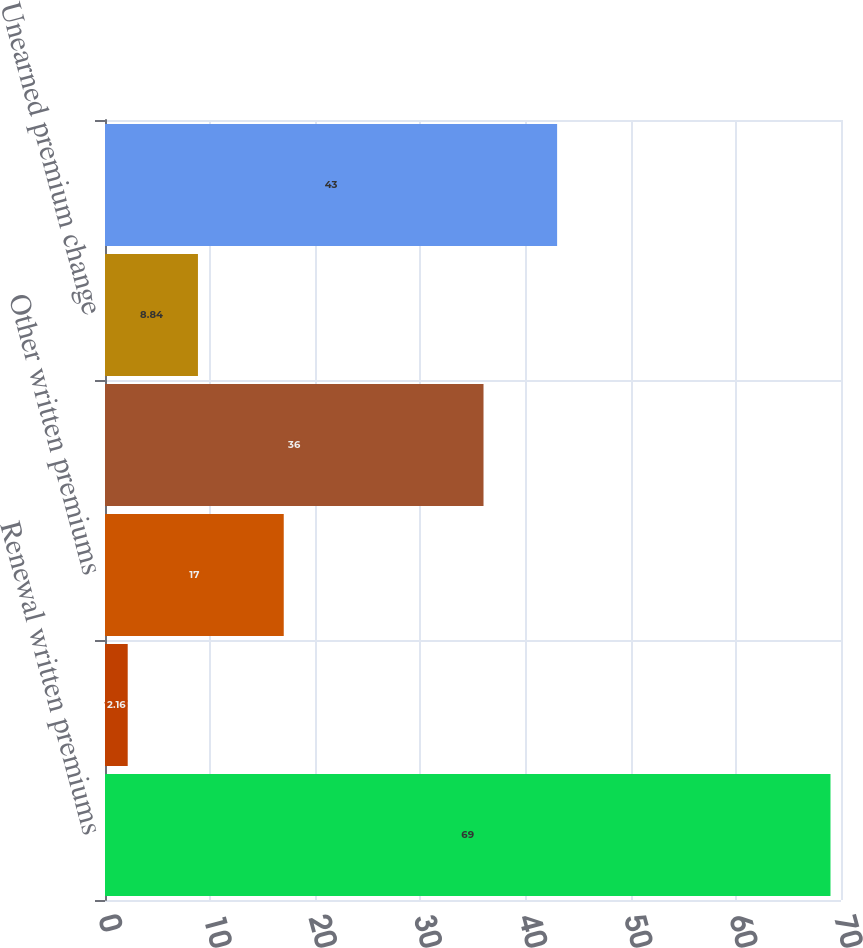<chart> <loc_0><loc_0><loc_500><loc_500><bar_chart><fcel>Renewal written premiums<fcel>New business written premiums<fcel>Other written premiums<fcel>Net written premiums<fcel>Unearned premium change<fcel>Earned premiums<nl><fcel>69<fcel>2.16<fcel>17<fcel>36<fcel>8.84<fcel>43<nl></chart> 